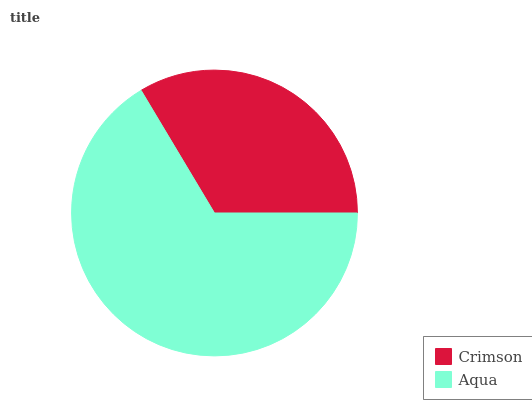Is Crimson the minimum?
Answer yes or no. Yes. Is Aqua the maximum?
Answer yes or no. Yes. Is Aqua the minimum?
Answer yes or no. No. Is Aqua greater than Crimson?
Answer yes or no. Yes. Is Crimson less than Aqua?
Answer yes or no. Yes. Is Crimson greater than Aqua?
Answer yes or no. No. Is Aqua less than Crimson?
Answer yes or no. No. Is Aqua the high median?
Answer yes or no. Yes. Is Crimson the low median?
Answer yes or no. Yes. Is Crimson the high median?
Answer yes or no. No. Is Aqua the low median?
Answer yes or no. No. 